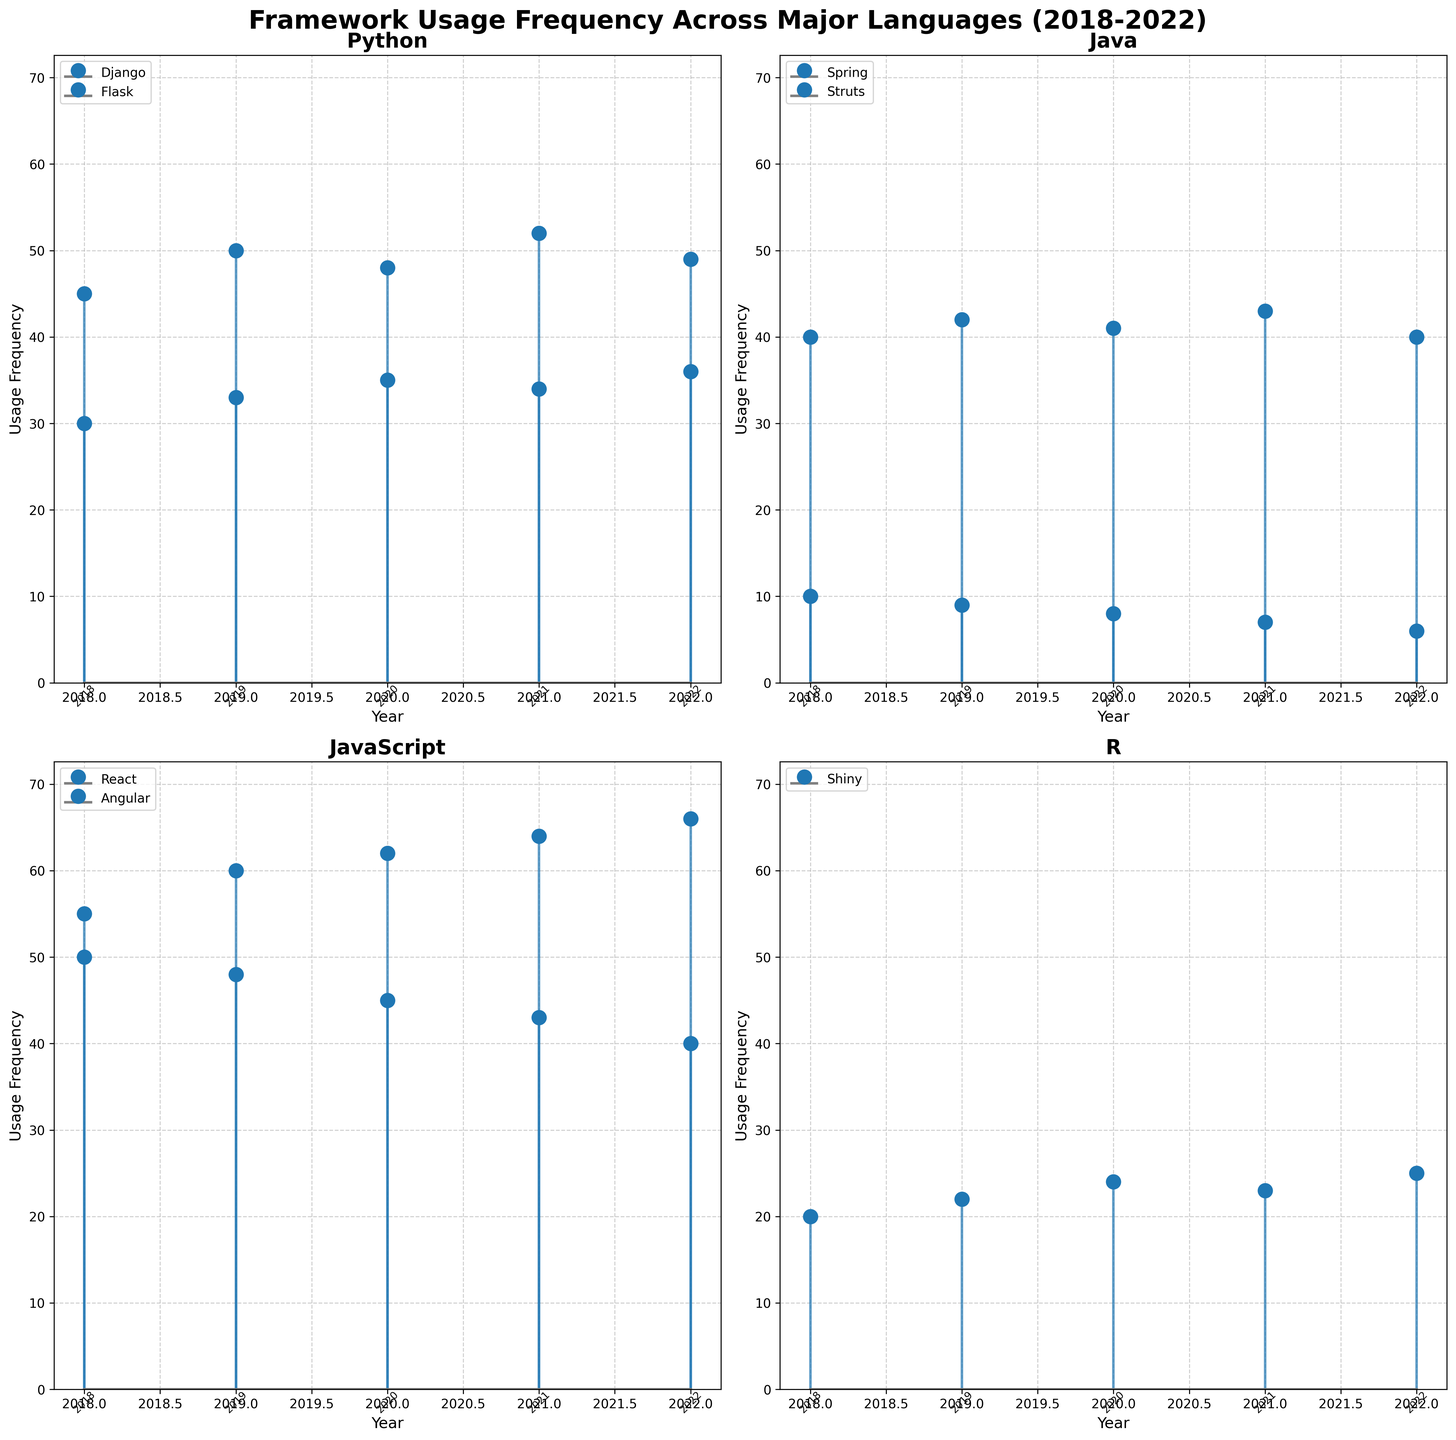What is the title of the entire figure? The title can be found at the top of the figure in bold text. It reads "Framework Usage Frequency Across Major Languages (2018-2022)."
Answer: Framework Usage Frequency Across Major Languages (2018-2022) Which framework has the highest usage frequency in 2022? By observing the stems in the subplot for each language's frameworks' usage in the year 2022, the highest point can be found for JavaScript's React with a frequency of 66.
Answer: React How does the usage frequency of Flask change from 2018 to 2022? Look at the stems for Flask in the Python subplot. The frequencies from 2018 to 2022 are 30, 33, 35, 34, and 36, showing a gradual increase overall.
Answer: Gradual increase Which language shows a decreasing trend for one of its frameworks over the years? By examining each subplot, Java's framework Struts shows a clear decreasing trend, dropping from 10 in 2018 to 6 in 2022.
Answer: Java (Struts) Compare the usage frequency of Spring and Django in 2021. Which one is higher? Look at the stems corresponding to the year 2021 for Spring in Java and Django in Python. Spring has a frequency of 43, and Django has 52. Thus, Django is higher.
Answer: Django What is the average usage frequency of Angular from 2018 to 2022? Add the frequencies for Angular across the years: 50, 48, 45, 43, and 40. The sum is 226. Divide by the number of years (5) to get the average: 226 / 5 = 45.2.
Answer: 45.2 What is the difference in usage frequency of Shiny from 2021 to 2022? Subtract the 2021 value from the 2022 value for Shiny in the R subplot. The frequencies are 25 in 2022 and 23 in 2021, so the difference is 25 - 23 = 2.
Answer: 2 Which frameworks show a consistent increase in usage frequency over the years? By surveying all subplots, React (JavaScript) and Flask (Python) show consistent increases. React goes from 55 to 66, and Flask goes from 30 to 36 over the 5 years.
Answer: React and Flask 